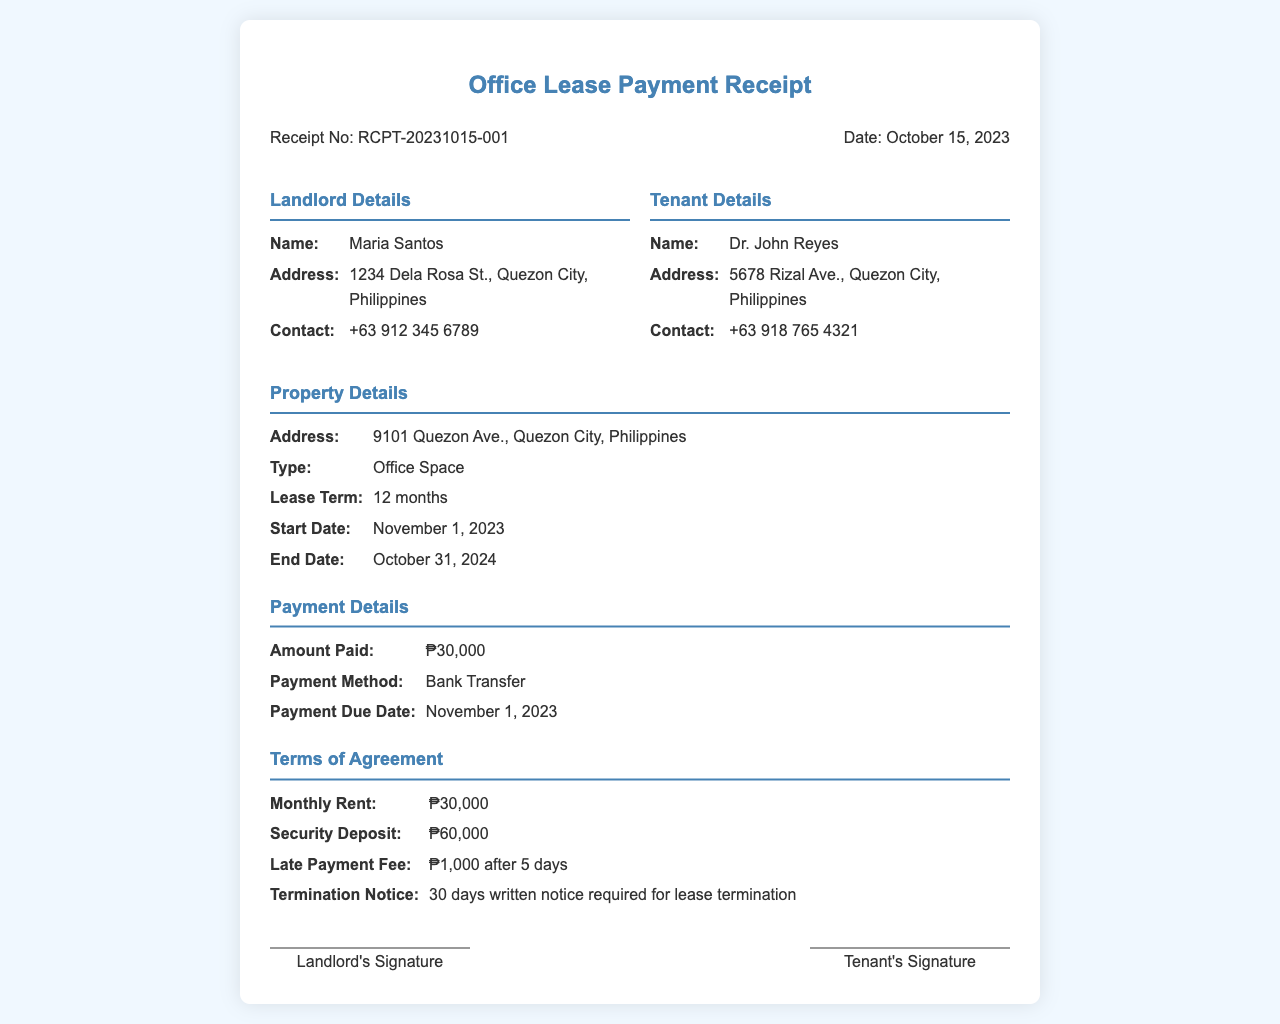What is the receipt number? The receipt number is a unique identifier for the payment receipt, visible in the header section.
Answer: RCPT-20231015-001 Who is the landlord? The landlord's name is provided under the landlord details section of the document.
Answer: Maria Santos What is the duration of the lease? The duration of the lease is indicated in the property details section, specifying the lease term.
Answer: 12 months What is the monthly rent? The monthly rent amount is specified under the terms of agreement section of the document.
Answer: ₱30,000 When does the lease start? The start date of the lease is mentioned in the property details section.
Answer: November 1, 2023 What payment method was used? The payment method is specified in the payment details section of the document.
Answer: Bank Transfer How much is the security deposit? The amount of the security deposit is indicated in the terms of agreement section.
Answer: ₱60,000 What is the late payment fee? The late payment fee is provided in the terms of agreement and specifies the conditions for incurring the fee.
Answer: ₱1,000 after 5 days What is the termination notice period? The termination notice period is mentioned in the terms of agreement section.
Answer: 30 days written notice required for lease termination 